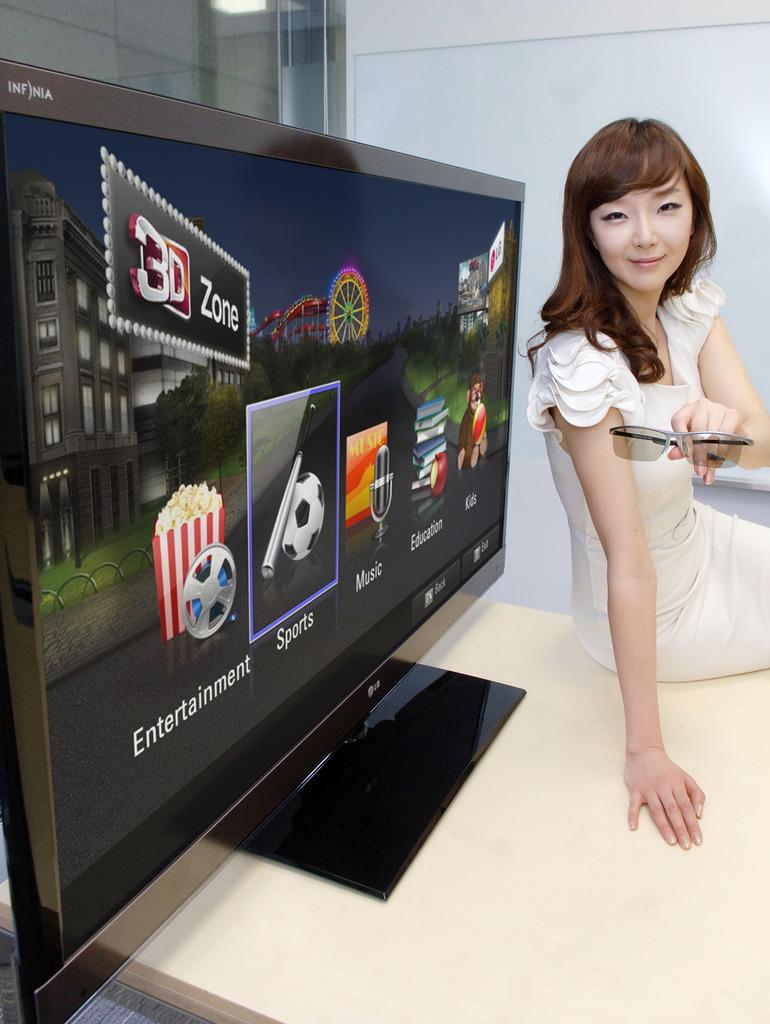What word is written under the box of popcorn?
Provide a succinct answer. Entertainment. What category is the highlighted box?
Your response must be concise. Sports. 